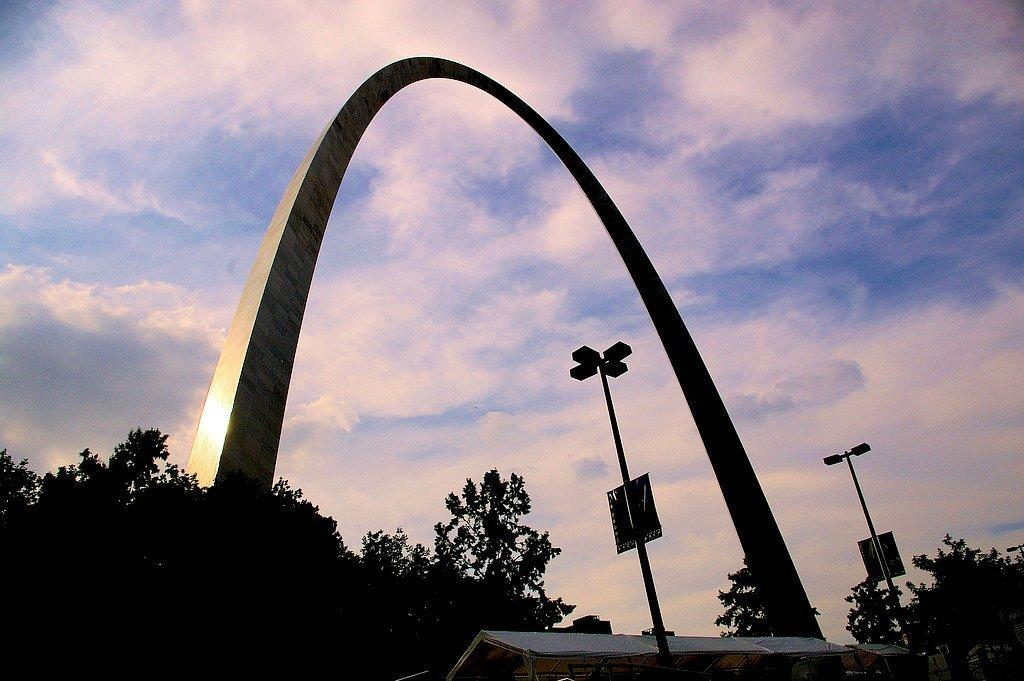What type of vegetation is visible on the ground in the image? There are trees on the ground in the image. What architectural feature is present in the image? There is a curved arch in the image. What type of lighting is present near the arch? Street lights are present in front of the arch. What can be seen in the sky in the image? The sky is visible in the image, and clouds are present. How does the doll feel about its journey in the image? There is no doll present in the image, so it is not possible to determine how a doll might feel about a journey. What is the stomach of the tree in the image? There is no mention of a tree's stomach in the image or the provided facts, as trees do not have stomachs. 